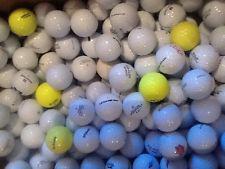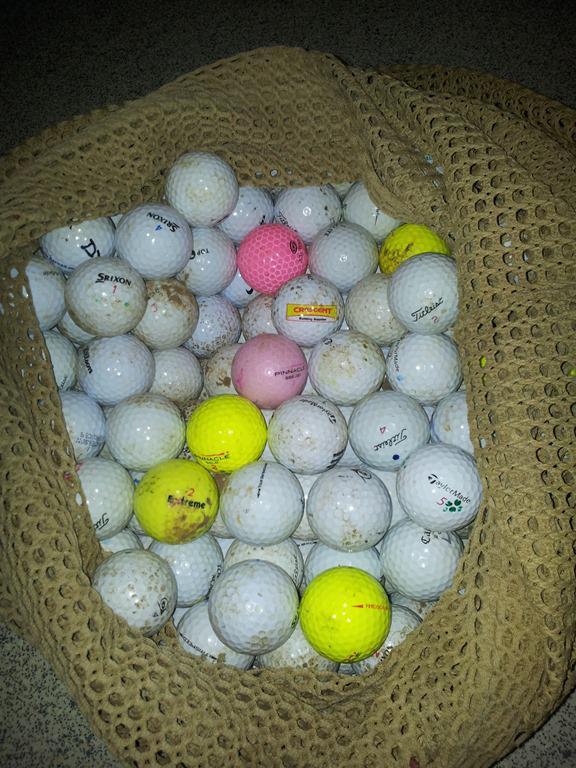The first image is the image on the left, the second image is the image on the right. Analyze the images presented: Is the assertion "There is at least one orange golf ball in the image on the left." valid? Answer yes or no. No. 